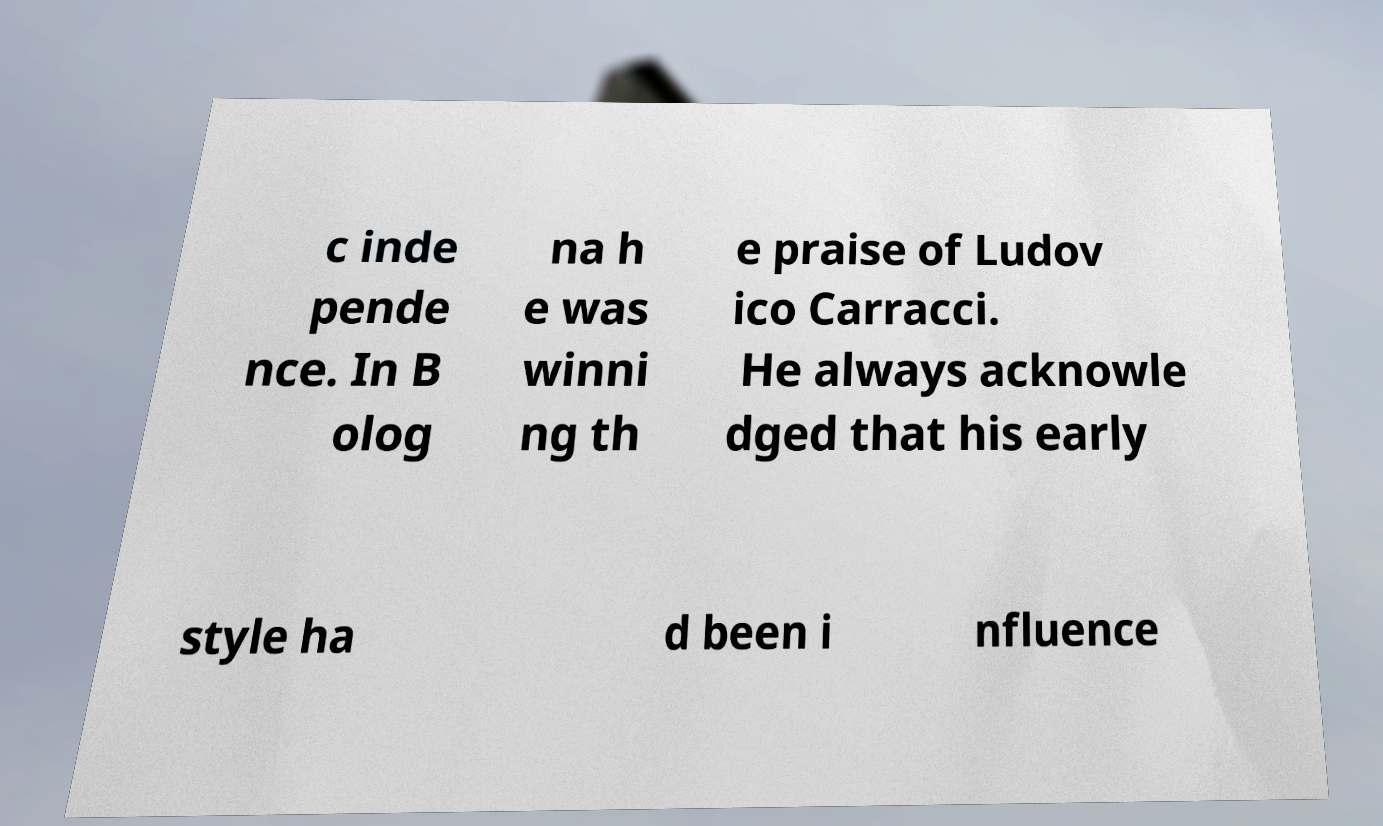Could you assist in decoding the text presented in this image and type it out clearly? c inde pende nce. In B olog na h e was winni ng th e praise of Ludov ico Carracci. He always acknowle dged that his early style ha d been i nfluence 